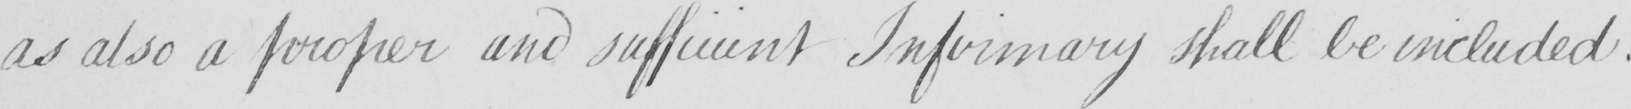What text is written in this handwritten line? as also a proper and sufficient Infirmary shall be included . 